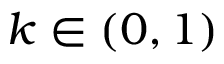Convert formula to latex. <formula><loc_0><loc_0><loc_500><loc_500>k \in ( 0 , 1 )</formula> 